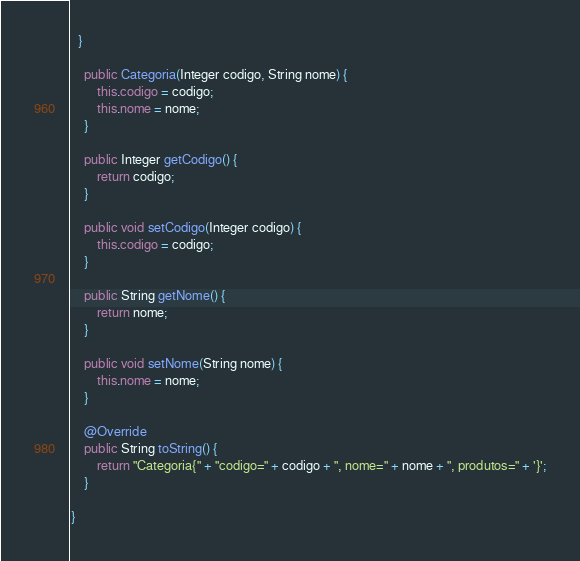<code> <loc_0><loc_0><loc_500><loc_500><_Java_>  }

    public Categoria(Integer codigo, String nome) {
        this.codigo = codigo;
        this.nome = nome;
    }

    public Integer getCodigo() {
        return codigo;
    }

    public void setCodigo(Integer codigo) {
        this.codigo = codigo;
    }

    public String getNome() {
        return nome;
    }

    public void setNome(String nome) {
        this.nome = nome;
    }

    @Override
    public String toString() {
        return "Categoria{" + "codigo=" + codigo + ", nome=" + nome + ", produtos=" + '}';
    }

}
</code> 